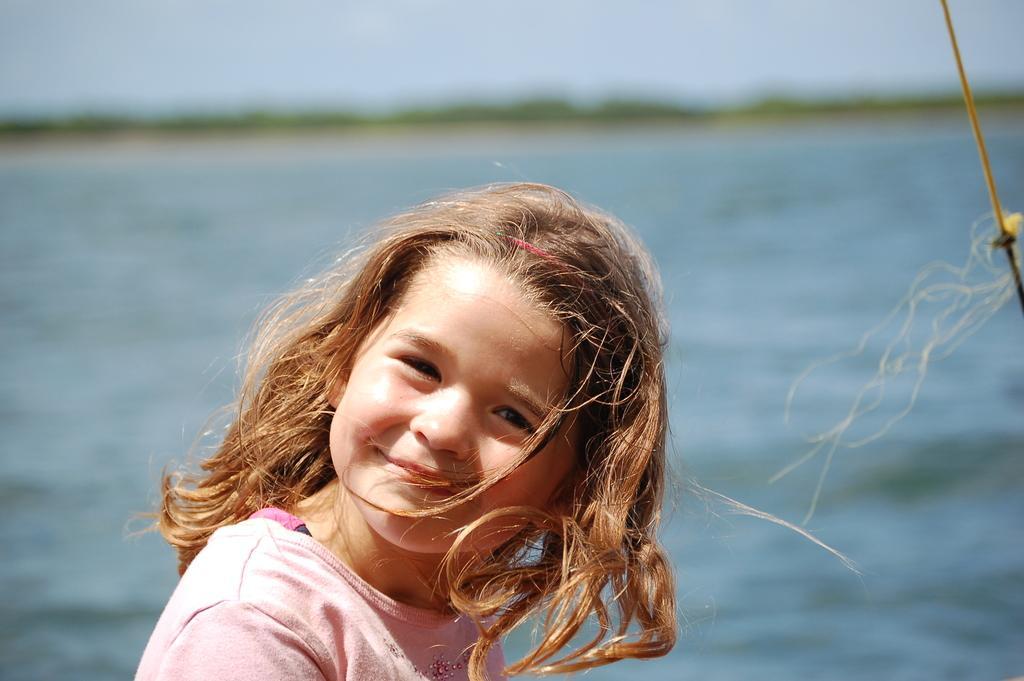In one or two sentences, can you explain what this image depicts? In this picture I can observe a girl wearing pink color T shirt. She is smiling. Behind her I can observe a river. The background is blurred. 